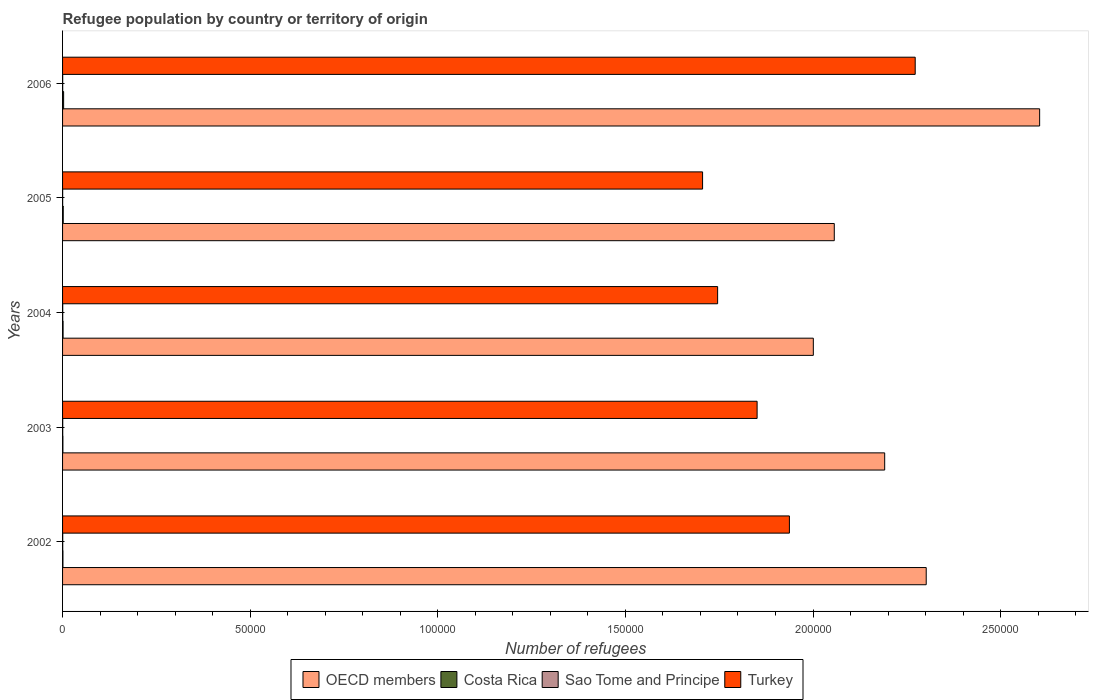How many groups of bars are there?
Keep it short and to the point. 5. How many bars are there on the 1st tick from the top?
Offer a terse response. 4. How many bars are there on the 4th tick from the bottom?
Your response must be concise. 4. In how many cases, is the number of bars for a given year not equal to the number of legend labels?
Your response must be concise. 0. What is the number of refugees in OECD members in 2002?
Give a very brief answer. 2.30e+05. Across all years, what is the maximum number of refugees in Costa Rica?
Offer a very short reply. 284. Across all years, what is the minimum number of refugees in Sao Tome and Principe?
Offer a very short reply. 24. What is the total number of refugees in Sao Tome and Principe in the graph?
Give a very brief answer. 176. What is the difference between the number of refugees in OECD members in 2004 and that in 2006?
Keep it short and to the point. -6.03e+04. What is the difference between the number of refugees in OECD members in 2006 and the number of refugees in Turkey in 2002?
Ensure brevity in your answer.  6.67e+04. What is the average number of refugees in OECD members per year?
Provide a succinct answer. 2.23e+05. In the year 2002, what is the difference between the number of refugees in Turkey and number of refugees in OECD members?
Your answer should be compact. -3.65e+04. In how many years, is the number of refugees in OECD members greater than 20000 ?
Offer a terse response. 5. What is the ratio of the number of refugees in OECD members in 2003 to that in 2004?
Provide a succinct answer. 1.1. What is the difference between the highest and the second highest number of refugees in OECD members?
Provide a short and direct response. 3.02e+04. What is the difference between the highest and the lowest number of refugees in Costa Rica?
Your answer should be very brief. 192. Is it the case that in every year, the sum of the number of refugees in Turkey and number of refugees in Costa Rica is greater than the sum of number of refugees in OECD members and number of refugees in Sao Tome and Principe?
Offer a very short reply. No. What does the 4th bar from the top in 2004 represents?
Provide a succinct answer. OECD members. How many bars are there?
Make the answer very short. 20. How many years are there in the graph?
Keep it short and to the point. 5. Are the values on the major ticks of X-axis written in scientific E-notation?
Provide a succinct answer. No. Does the graph contain any zero values?
Keep it short and to the point. No. Where does the legend appear in the graph?
Make the answer very short. Bottom center. How many legend labels are there?
Keep it short and to the point. 4. How are the legend labels stacked?
Provide a succinct answer. Horizontal. What is the title of the graph?
Ensure brevity in your answer.  Refugee population by country or territory of origin. What is the label or title of the X-axis?
Provide a short and direct response. Number of refugees. What is the label or title of the Y-axis?
Keep it short and to the point. Years. What is the Number of refugees in OECD members in 2002?
Your answer should be very brief. 2.30e+05. What is the Number of refugees in Sao Tome and Principe in 2002?
Your answer should be compact. 39. What is the Number of refugees of Turkey in 2002?
Provide a short and direct response. 1.94e+05. What is the Number of refugees in OECD members in 2003?
Ensure brevity in your answer.  2.19e+05. What is the Number of refugees of Costa Rica in 2003?
Offer a very short reply. 92. What is the Number of refugees of Sao Tome and Principe in 2003?
Offer a very short reply. 42. What is the Number of refugees of Turkey in 2003?
Provide a short and direct response. 1.85e+05. What is the Number of refugees of OECD members in 2004?
Your answer should be compact. 2.00e+05. What is the Number of refugees of Costa Rica in 2004?
Offer a very short reply. 138. What is the Number of refugees in Turkey in 2004?
Offer a terse response. 1.75e+05. What is the Number of refugees in OECD members in 2005?
Your response must be concise. 2.06e+05. What is the Number of refugees in Costa Rica in 2005?
Give a very brief answer. 178. What is the Number of refugees of Sao Tome and Principe in 2005?
Provide a short and direct response. 24. What is the Number of refugees of Turkey in 2005?
Ensure brevity in your answer.  1.71e+05. What is the Number of refugees of OECD members in 2006?
Give a very brief answer. 2.60e+05. What is the Number of refugees of Costa Rica in 2006?
Make the answer very short. 284. What is the Number of refugees of Turkey in 2006?
Provide a short and direct response. 2.27e+05. Across all years, what is the maximum Number of refugees of OECD members?
Offer a terse response. 2.60e+05. Across all years, what is the maximum Number of refugees of Costa Rica?
Your answer should be very brief. 284. Across all years, what is the maximum Number of refugees of Turkey?
Ensure brevity in your answer.  2.27e+05. Across all years, what is the minimum Number of refugees in OECD members?
Your response must be concise. 2.00e+05. Across all years, what is the minimum Number of refugees of Costa Rica?
Provide a succinct answer. 92. Across all years, what is the minimum Number of refugees in Sao Tome and Principe?
Your answer should be very brief. 24. Across all years, what is the minimum Number of refugees in Turkey?
Make the answer very short. 1.71e+05. What is the total Number of refugees of OECD members in the graph?
Ensure brevity in your answer.  1.12e+06. What is the total Number of refugees of Costa Rica in the graph?
Provide a short and direct response. 790. What is the total Number of refugees in Sao Tome and Principe in the graph?
Provide a short and direct response. 176. What is the total Number of refugees in Turkey in the graph?
Offer a very short reply. 9.51e+05. What is the difference between the Number of refugees of OECD members in 2002 and that in 2003?
Your answer should be compact. 1.11e+04. What is the difference between the Number of refugees in Turkey in 2002 and that in 2003?
Give a very brief answer. 8606. What is the difference between the Number of refugees in OECD members in 2002 and that in 2004?
Ensure brevity in your answer.  3.01e+04. What is the difference between the Number of refugees in Turkey in 2002 and that in 2004?
Provide a succinct answer. 1.91e+04. What is the difference between the Number of refugees of OECD members in 2002 and that in 2005?
Offer a very short reply. 2.45e+04. What is the difference between the Number of refugees of Costa Rica in 2002 and that in 2005?
Your response must be concise. -80. What is the difference between the Number of refugees in Turkey in 2002 and that in 2005?
Provide a short and direct response. 2.31e+04. What is the difference between the Number of refugees of OECD members in 2002 and that in 2006?
Give a very brief answer. -3.02e+04. What is the difference between the Number of refugees in Costa Rica in 2002 and that in 2006?
Provide a succinct answer. -186. What is the difference between the Number of refugees of Sao Tome and Principe in 2002 and that in 2006?
Your answer should be compact. 7. What is the difference between the Number of refugees of Turkey in 2002 and that in 2006?
Ensure brevity in your answer.  -3.35e+04. What is the difference between the Number of refugees of OECD members in 2003 and that in 2004?
Make the answer very short. 1.90e+04. What is the difference between the Number of refugees in Costa Rica in 2003 and that in 2004?
Your answer should be very brief. -46. What is the difference between the Number of refugees in Sao Tome and Principe in 2003 and that in 2004?
Provide a short and direct response. 3. What is the difference between the Number of refugees of Turkey in 2003 and that in 2004?
Offer a very short reply. 1.05e+04. What is the difference between the Number of refugees of OECD members in 2003 and that in 2005?
Make the answer very short. 1.34e+04. What is the difference between the Number of refugees in Costa Rica in 2003 and that in 2005?
Provide a succinct answer. -86. What is the difference between the Number of refugees in Sao Tome and Principe in 2003 and that in 2005?
Give a very brief answer. 18. What is the difference between the Number of refugees of Turkey in 2003 and that in 2005?
Your answer should be very brief. 1.45e+04. What is the difference between the Number of refugees in OECD members in 2003 and that in 2006?
Offer a very short reply. -4.13e+04. What is the difference between the Number of refugees of Costa Rica in 2003 and that in 2006?
Your answer should be compact. -192. What is the difference between the Number of refugees in Sao Tome and Principe in 2003 and that in 2006?
Provide a short and direct response. 10. What is the difference between the Number of refugees of Turkey in 2003 and that in 2006?
Ensure brevity in your answer.  -4.21e+04. What is the difference between the Number of refugees of OECD members in 2004 and that in 2005?
Give a very brief answer. -5583. What is the difference between the Number of refugees of Sao Tome and Principe in 2004 and that in 2005?
Keep it short and to the point. 15. What is the difference between the Number of refugees in Turkey in 2004 and that in 2005?
Your answer should be compact. 4007. What is the difference between the Number of refugees in OECD members in 2004 and that in 2006?
Provide a succinct answer. -6.03e+04. What is the difference between the Number of refugees of Costa Rica in 2004 and that in 2006?
Make the answer very short. -146. What is the difference between the Number of refugees of Sao Tome and Principe in 2004 and that in 2006?
Your answer should be very brief. 7. What is the difference between the Number of refugees of Turkey in 2004 and that in 2006?
Your response must be concise. -5.27e+04. What is the difference between the Number of refugees in OECD members in 2005 and that in 2006?
Give a very brief answer. -5.47e+04. What is the difference between the Number of refugees in Costa Rica in 2005 and that in 2006?
Your answer should be compact. -106. What is the difference between the Number of refugees in Turkey in 2005 and that in 2006?
Your answer should be very brief. -5.67e+04. What is the difference between the Number of refugees of OECD members in 2002 and the Number of refugees of Costa Rica in 2003?
Your response must be concise. 2.30e+05. What is the difference between the Number of refugees in OECD members in 2002 and the Number of refugees in Sao Tome and Principe in 2003?
Provide a succinct answer. 2.30e+05. What is the difference between the Number of refugees in OECD members in 2002 and the Number of refugees in Turkey in 2003?
Ensure brevity in your answer.  4.51e+04. What is the difference between the Number of refugees of Costa Rica in 2002 and the Number of refugees of Sao Tome and Principe in 2003?
Ensure brevity in your answer.  56. What is the difference between the Number of refugees of Costa Rica in 2002 and the Number of refugees of Turkey in 2003?
Your answer should be very brief. -1.85e+05. What is the difference between the Number of refugees in Sao Tome and Principe in 2002 and the Number of refugees in Turkey in 2003?
Provide a succinct answer. -1.85e+05. What is the difference between the Number of refugees in OECD members in 2002 and the Number of refugees in Costa Rica in 2004?
Your response must be concise. 2.30e+05. What is the difference between the Number of refugees of OECD members in 2002 and the Number of refugees of Sao Tome and Principe in 2004?
Provide a short and direct response. 2.30e+05. What is the difference between the Number of refugees of OECD members in 2002 and the Number of refugees of Turkey in 2004?
Your answer should be compact. 5.56e+04. What is the difference between the Number of refugees of Costa Rica in 2002 and the Number of refugees of Turkey in 2004?
Make the answer very short. -1.74e+05. What is the difference between the Number of refugees of Sao Tome and Principe in 2002 and the Number of refugees of Turkey in 2004?
Ensure brevity in your answer.  -1.75e+05. What is the difference between the Number of refugees of OECD members in 2002 and the Number of refugees of Costa Rica in 2005?
Keep it short and to the point. 2.30e+05. What is the difference between the Number of refugees in OECD members in 2002 and the Number of refugees in Sao Tome and Principe in 2005?
Provide a short and direct response. 2.30e+05. What is the difference between the Number of refugees of OECD members in 2002 and the Number of refugees of Turkey in 2005?
Provide a short and direct response. 5.96e+04. What is the difference between the Number of refugees of Costa Rica in 2002 and the Number of refugees of Sao Tome and Principe in 2005?
Offer a very short reply. 74. What is the difference between the Number of refugees in Costa Rica in 2002 and the Number of refugees in Turkey in 2005?
Ensure brevity in your answer.  -1.70e+05. What is the difference between the Number of refugees in Sao Tome and Principe in 2002 and the Number of refugees in Turkey in 2005?
Make the answer very short. -1.71e+05. What is the difference between the Number of refugees in OECD members in 2002 and the Number of refugees in Costa Rica in 2006?
Provide a succinct answer. 2.30e+05. What is the difference between the Number of refugees in OECD members in 2002 and the Number of refugees in Sao Tome and Principe in 2006?
Keep it short and to the point. 2.30e+05. What is the difference between the Number of refugees of OECD members in 2002 and the Number of refugees of Turkey in 2006?
Your response must be concise. 2933. What is the difference between the Number of refugees of Costa Rica in 2002 and the Number of refugees of Sao Tome and Principe in 2006?
Ensure brevity in your answer.  66. What is the difference between the Number of refugees of Costa Rica in 2002 and the Number of refugees of Turkey in 2006?
Ensure brevity in your answer.  -2.27e+05. What is the difference between the Number of refugees of Sao Tome and Principe in 2002 and the Number of refugees of Turkey in 2006?
Offer a terse response. -2.27e+05. What is the difference between the Number of refugees of OECD members in 2003 and the Number of refugees of Costa Rica in 2004?
Your response must be concise. 2.19e+05. What is the difference between the Number of refugees in OECD members in 2003 and the Number of refugees in Sao Tome and Principe in 2004?
Offer a terse response. 2.19e+05. What is the difference between the Number of refugees in OECD members in 2003 and the Number of refugees in Turkey in 2004?
Keep it short and to the point. 4.45e+04. What is the difference between the Number of refugees of Costa Rica in 2003 and the Number of refugees of Sao Tome and Principe in 2004?
Give a very brief answer. 53. What is the difference between the Number of refugees of Costa Rica in 2003 and the Number of refugees of Turkey in 2004?
Give a very brief answer. -1.74e+05. What is the difference between the Number of refugees in Sao Tome and Principe in 2003 and the Number of refugees in Turkey in 2004?
Ensure brevity in your answer.  -1.75e+05. What is the difference between the Number of refugees in OECD members in 2003 and the Number of refugees in Costa Rica in 2005?
Your response must be concise. 2.19e+05. What is the difference between the Number of refugees in OECD members in 2003 and the Number of refugees in Sao Tome and Principe in 2005?
Ensure brevity in your answer.  2.19e+05. What is the difference between the Number of refugees in OECD members in 2003 and the Number of refugees in Turkey in 2005?
Make the answer very short. 4.85e+04. What is the difference between the Number of refugees in Costa Rica in 2003 and the Number of refugees in Turkey in 2005?
Provide a succinct answer. -1.70e+05. What is the difference between the Number of refugees of Sao Tome and Principe in 2003 and the Number of refugees of Turkey in 2005?
Your answer should be compact. -1.71e+05. What is the difference between the Number of refugees of OECD members in 2003 and the Number of refugees of Costa Rica in 2006?
Ensure brevity in your answer.  2.19e+05. What is the difference between the Number of refugees of OECD members in 2003 and the Number of refugees of Sao Tome and Principe in 2006?
Your response must be concise. 2.19e+05. What is the difference between the Number of refugees of OECD members in 2003 and the Number of refugees of Turkey in 2006?
Offer a terse response. -8136. What is the difference between the Number of refugees of Costa Rica in 2003 and the Number of refugees of Turkey in 2006?
Give a very brief answer. -2.27e+05. What is the difference between the Number of refugees in Sao Tome and Principe in 2003 and the Number of refugees in Turkey in 2006?
Provide a short and direct response. -2.27e+05. What is the difference between the Number of refugees of OECD members in 2004 and the Number of refugees of Costa Rica in 2005?
Provide a short and direct response. 2.00e+05. What is the difference between the Number of refugees in OECD members in 2004 and the Number of refugees in Sao Tome and Principe in 2005?
Give a very brief answer. 2.00e+05. What is the difference between the Number of refugees of OECD members in 2004 and the Number of refugees of Turkey in 2005?
Make the answer very short. 2.95e+04. What is the difference between the Number of refugees of Costa Rica in 2004 and the Number of refugees of Sao Tome and Principe in 2005?
Provide a short and direct response. 114. What is the difference between the Number of refugees in Costa Rica in 2004 and the Number of refugees in Turkey in 2005?
Your response must be concise. -1.70e+05. What is the difference between the Number of refugees of Sao Tome and Principe in 2004 and the Number of refugees of Turkey in 2005?
Make the answer very short. -1.71e+05. What is the difference between the Number of refugees in OECD members in 2004 and the Number of refugees in Costa Rica in 2006?
Keep it short and to the point. 2.00e+05. What is the difference between the Number of refugees of OECD members in 2004 and the Number of refugees of Sao Tome and Principe in 2006?
Keep it short and to the point. 2.00e+05. What is the difference between the Number of refugees of OECD members in 2004 and the Number of refugees of Turkey in 2006?
Provide a short and direct response. -2.72e+04. What is the difference between the Number of refugees in Costa Rica in 2004 and the Number of refugees in Sao Tome and Principe in 2006?
Provide a succinct answer. 106. What is the difference between the Number of refugees in Costa Rica in 2004 and the Number of refugees in Turkey in 2006?
Offer a terse response. -2.27e+05. What is the difference between the Number of refugees in Sao Tome and Principe in 2004 and the Number of refugees in Turkey in 2006?
Make the answer very short. -2.27e+05. What is the difference between the Number of refugees of OECD members in 2005 and the Number of refugees of Costa Rica in 2006?
Your answer should be compact. 2.05e+05. What is the difference between the Number of refugees in OECD members in 2005 and the Number of refugees in Sao Tome and Principe in 2006?
Offer a very short reply. 2.06e+05. What is the difference between the Number of refugees in OECD members in 2005 and the Number of refugees in Turkey in 2006?
Provide a short and direct response. -2.16e+04. What is the difference between the Number of refugees in Costa Rica in 2005 and the Number of refugees in Sao Tome and Principe in 2006?
Offer a terse response. 146. What is the difference between the Number of refugees in Costa Rica in 2005 and the Number of refugees in Turkey in 2006?
Offer a terse response. -2.27e+05. What is the difference between the Number of refugees in Sao Tome and Principe in 2005 and the Number of refugees in Turkey in 2006?
Ensure brevity in your answer.  -2.27e+05. What is the average Number of refugees of OECD members per year?
Provide a succinct answer. 2.23e+05. What is the average Number of refugees of Costa Rica per year?
Your response must be concise. 158. What is the average Number of refugees of Sao Tome and Principe per year?
Your answer should be very brief. 35.2. What is the average Number of refugees of Turkey per year?
Make the answer very short. 1.90e+05. In the year 2002, what is the difference between the Number of refugees in OECD members and Number of refugees in Costa Rica?
Your answer should be compact. 2.30e+05. In the year 2002, what is the difference between the Number of refugees in OECD members and Number of refugees in Sao Tome and Principe?
Keep it short and to the point. 2.30e+05. In the year 2002, what is the difference between the Number of refugees of OECD members and Number of refugees of Turkey?
Your answer should be very brief. 3.65e+04. In the year 2002, what is the difference between the Number of refugees in Costa Rica and Number of refugees in Sao Tome and Principe?
Your answer should be very brief. 59. In the year 2002, what is the difference between the Number of refugees of Costa Rica and Number of refugees of Turkey?
Your answer should be very brief. -1.94e+05. In the year 2002, what is the difference between the Number of refugees of Sao Tome and Principe and Number of refugees of Turkey?
Your answer should be very brief. -1.94e+05. In the year 2003, what is the difference between the Number of refugees of OECD members and Number of refugees of Costa Rica?
Give a very brief answer. 2.19e+05. In the year 2003, what is the difference between the Number of refugees in OECD members and Number of refugees in Sao Tome and Principe?
Your answer should be compact. 2.19e+05. In the year 2003, what is the difference between the Number of refugees of OECD members and Number of refugees of Turkey?
Offer a very short reply. 3.40e+04. In the year 2003, what is the difference between the Number of refugees of Costa Rica and Number of refugees of Turkey?
Ensure brevity in your answer.  -1.85e+05. In the year 2003, what is the difference between the Number of refugees of Sao Tome and Principe and Number of refugees of Turkey?
Offer a terse response. -1.85e+05. In the year 2004, what is the difference between the Number of refugees of OECD members and Number of refugees of Costa Rica?
Offer a terse response. 2.00e+05. In the year 2004, what is the difference between the Number of refugees of OECD members and Number of refugees of Sao Tome and Principe?
Provide a short and direct response. 2.00e+05. In the year 2004, what is the difference between the Number of refugees of OECD members and Number of refugees of Turkey?
Provide a short and direct response. 2.55e+04. In the year 2004, what is the difference between the Number of refugees in Costa Rica and Number of refugees in Sao Tome and Principe?
Offer a terse response. 99. In the year 2004, what is the difference between the Number of refugees in Costa Rica and Number of refugees in Turkey?
Provide a short and direct response. -1.74e+05. In the year 2004, what is the difference between the Number of refugees of Sao Tome and Principe and Number of refugees of Turkey?
Offer a very short reply. -1.75e+05. In the year 2005, what is the difference between the Number of refugees in OECD members and Number of refugees in Costa Rica?
Offer a very short reply. 2.05e+05. In the year 2005, what is the difference between the Number of refugees in OECD members and Number of refugees in Sao Tome and Principe?
Your response must be concise. 2.06e+05. In the year 2005, what is the difference between the Number of refugees of OECD members and Number of refugees of Turkey?
Give a very brief answer. 3.51e+04. In the year 2005, what is the difference between the Number of refugees of Costa Rica and Number of refugees of Sao Tome and Principe?
Your response must be concise. 154. In the year 2005, what is the difference between the Number of refugees of Costa Rica and Number of refugees of Turkey?
Provide a succinct answer. -1.70e+05. In the year 2005, what is the difference between the Number of refugees in Sao Tome and Principe and Number of refugees in Turkey?
Keep it short and to the point. -1.71e+05. In the year 2006, what is the difference between the Number of refugees in OECD members and Number of refugees in Costa Rica?
Offer a terse response. 2.60e+05. In the year 2006, what is the difference between the Number of refugees of OECD members and Number of refugees of Sao Tome and Principe?
Make the answer very short. 2.60e+05. In the year 2006, what is the difference between the Number of refugees of OECD members and Number of refugees of Turkey?
Make the answer very short. 3.32e+04. In the year 2006, what is the difference between the Number of refugees of Costa Rica and Number of refugees of Sao Tome and Principe?
Provide a succinct answer. 252. In the year 2006, what is the difference between the Number of refugees in Costa Rica and Number of refugees in Turkey?
Provide a short and direct response. -2.27e+05. In the year 2006, what is the difference between the Number of refugees of Sao Tome and Principe and Number of refugees of Turkey?
Make the answer very short. -2.27e+05. What is the ratio of the Number of refugees of OECD members in 2002 to that in 2003?
Provide a succinct answer. 1.05. What is the ratio of the Number of refugees in Costa Rica in 2002 to that in 2003?
Provide a succinct answer. 1.07. What is the ratio of the Number of refugees of Sao Tome and Principe in 2002 to that in 2003?
Offer a terse response. 0.93. What is the ratio of the Number of refugees in Turkey in 2002 to that in 2003?
Provide a succinct answer. 1.05. What is the ratio of the Number of refugees of OECD members in 2002 to that in 2004?
Your answer should be compact. 1.15. What is the ratio of the Number of refugees in Costa Rica in 2002 to that in 2004?
Ensure brevity in your answer.  0.71. What is the ratio of the Number of refugees of Sao Tome and Principe in 2002 to that in 2004?
Your answer should be compact. 1. What is the ratio of the Number of refugees of Turkey in 2002 to that in 2004?
Your answer should be compact. 1.11. What is the ratio of the Number of refugees in OECD members in 2002 to that in 2005?
Give a very brief answer. 1.12. What is the ratio of the Number of refugees in Costa Rica in 2002 to that in 2005?
Offer a very short reply. 0.55. What is the ratio of the Number of refugees in Sao Tome and Principe in 2002 to that in 2005?
Make the answer very short. 1.62. What is the ratio of the Number of refugees in Turkey in 2002 to that in 2005?
Offer a very short reply. 1.14. What is the ratio of the Number of refugees in OECD members in 2002 to that in 2006?
Provide a short and direct response. 0.88. What is the ratio of the Number of refugees in Costa Rica in 2002 to that in 2006?
Your answer should be compact. 0.35. What is the ratio of the Number of refugees of Sao Tome and Principe in 2002 to that in 2006?
Offer a terse response. 1.22. What is the ratio of the Number of refugees in Turkey in 2002 to that in 2006?
Offer a very short reply. 0.85. What is the ratio of the Number of refugees of OECD members in 2003 to that in 2004?
Offer a very short reply. 1.09. What is the ratio of the Number of refugees of Costa Rica in 2003 to that in 2004?
Your answer should be compact. 0.67. What is the ratio of the Number of refugees in Turkey in 2003 to that in 2004?
Keep it short and to the point. 1.06. What is the ratio of the Number of refugees in OECD members in 2003 to that in 2005?
Provide a short and direct response. 1.07. What is the ratio of the Number of refugees of Costa Rica in 2003 to that in 2005?
Provide a short and direct response. 0.52. What is the ratio of the Number of refugees in Sao Tome and Principe in 2003 to that in 2005?
Offer a terse response. 1.75. What is the ratio of the Number of refugees in Turkey in 2003 to that in 2005?
Your answer should be very brief. 1.09. What is the ratio of the Number of refugees of OECD members in 2003 to that in 2006?
Make the answer very short. 0.84. What is the ratio of the Number of refugees of Costa Rica in 2003 to that in 2006?
Keep it short and to the point. 0.32. What is the ratio of the Number of refugees in Sao Tome and Principe in 2003 to that in 2006?
Offer a very short reply. 1.31. What is the ratio of the Number of refugees in Turkey in 2003 to that in 2006?
Offer a very short reply. 0.81. What is the ratio of the Number of refugees of OECD members in 2004 to that in 2005?
Offer a very short reply. 0.97. What is the ratio of the Number of refugees of Costa Rica in 2004 to that in 2005?
Offer a very short reply. 0.78. What is the ratio of the Number of refugees in Sao Tome and Principe in 2004 to that in 2005?
Your answer should be very brief. 1.62. What is the ratio of the Number of refugees in Turkey in 2004 to that in 2005?
Offer a terse response. 1.02. What is the ratio of the Number of refugees of OECD members in 2004 to that in 2006?
Your answer should be very brief. 0.77. What is the ratio of the Number of refugees in Costa Rica in 2004 to that in 2006?
Provide a short and direct response. 0.49. What is the ratio of the Number of refugees in Sao Tome and Principe in 2004 to that in 2006?
Make the answer very short. 1.22. What is the ratio of the Number of refugees of Turkey in 2004 to that in 2006?
Your response must be concise. 0.77. What is the ratio of the Number of refugees in OECD members in 2005 to that in 2006?
Give a very brief answer. 0.79. What is the ratio of the Number of refugees of Costa Rica in 2005 to that in 2006?
Offer a terse response. 0.63. What is the ratio of the Number of refugees in Turkey in 2005 to that in 2006?
Provide a succinct answer. 0.75. What is the difference between the highest and the second highest Number of refugees of OECD members?
Keep it short and to the point. 3.02e+04. What is the difference between the highest and the second highest Number of refugees in Costa Rica?
Your response must be concise. 106. What is the difference between the highest and the second highest Number of refugees of Sao Tome and Principe?
Keep it short and to the point. 3. What is the difference between the highest and the second highest Number of refugees in Turkey?
Keep it short and to the point. 3.35e+04. What is the difference between the highest and the lowest Number of refugees in OECD members?
Ensure brevity in your answer.  6.03e+04. What is the difference between the highest and the lowest Number of refugees in Costa Rica?
Make the answer very short. 192. What is the difference between the highest and the lowest Number of refugees of Turkey?
Make the answer very short. 5.67e+04. 